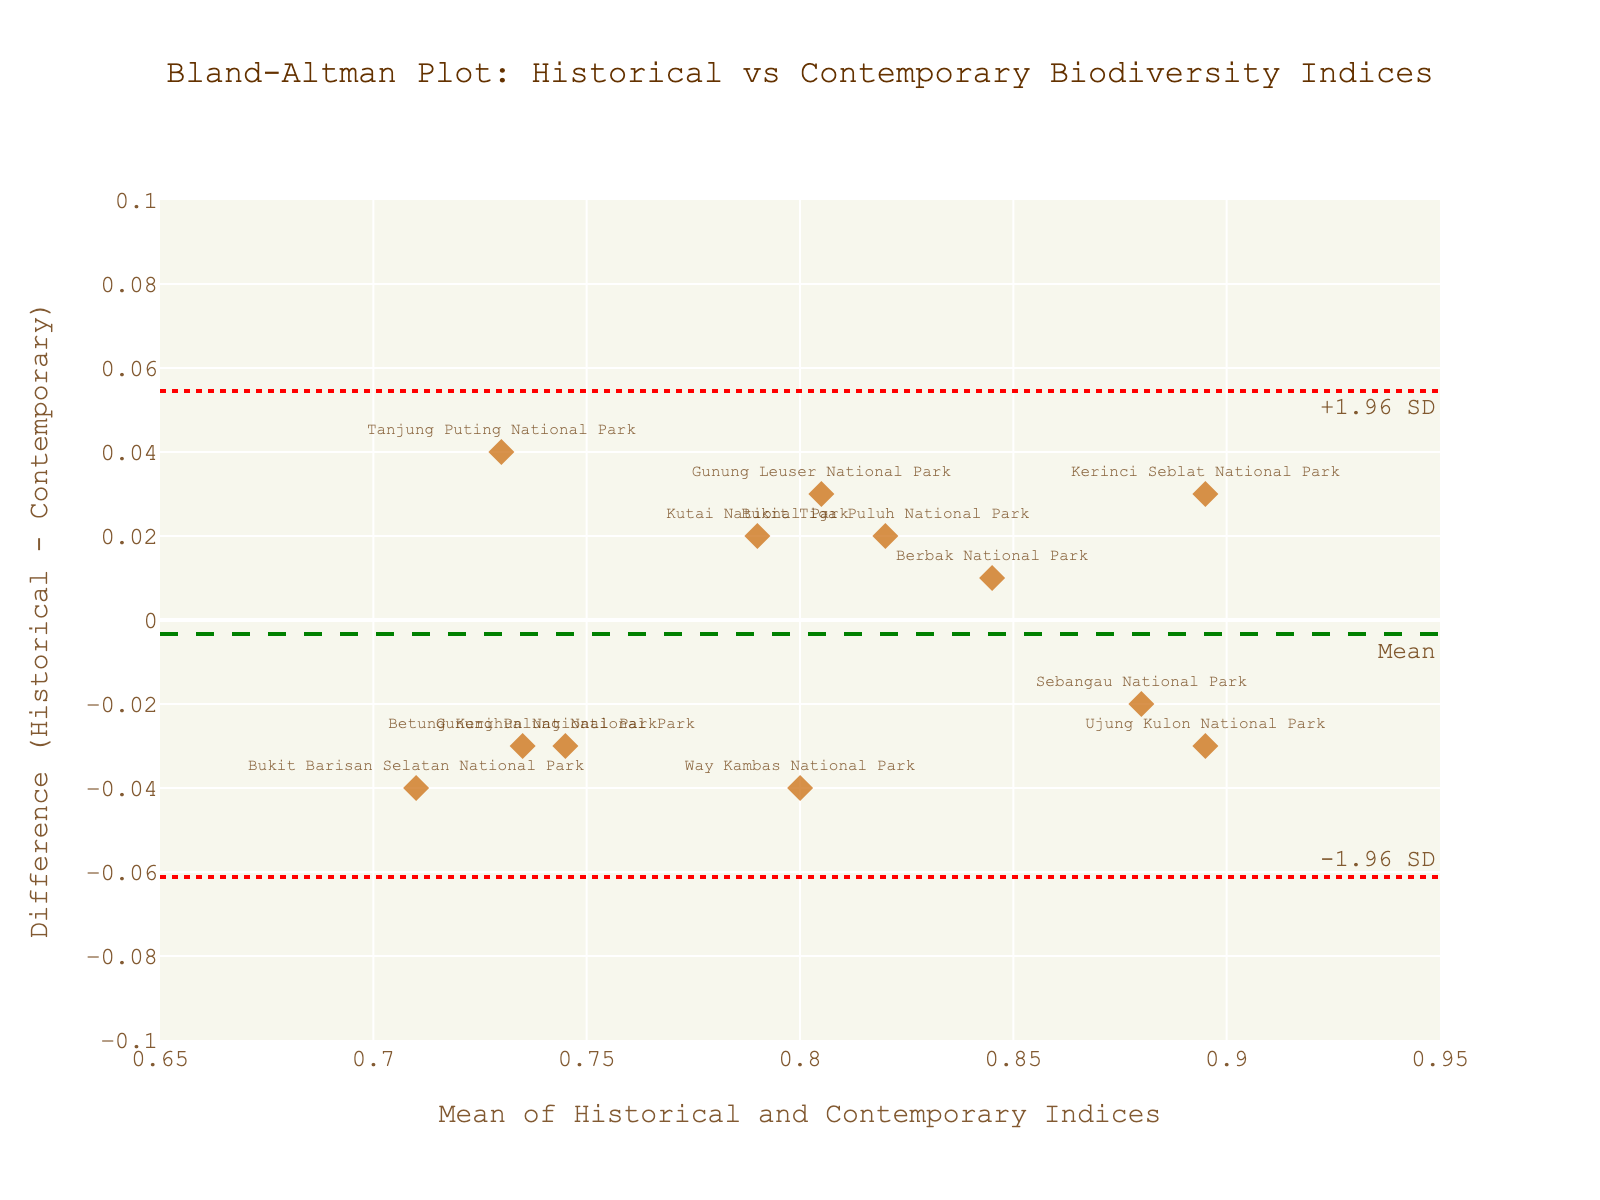What is the title of the figure? Look at the top of the figure where the title is displayed in a large font.
Answer: Bland-Altman Plot: Historical vs Contemporary Biodiversity Indices What are the x-axis and y-axis titles on the plot? The x-axis title is at the bottom of the plot, and the y-axis title is to the left of the plot.
Answer: x-axis: Mean of Historical and Contemporary Indices, y-axis: Difference (Historical - Contemporary) How many data points are there in the plot? Count the total number of markers (diamonds) on the plot.
Answer: 12 Which national park is represented by the data point with the largest positive difference? Identify the data point with the highest y-value and check the associated label.
Answer: Kerinci Seblat National Park What is the mean difference between the historical and contemporary indices? Locate the horizontal line labeled "Mean" and observe the y-value it crosses.
Answer: 0 What are the upper and lower limits of agreement? Observe the positions of the dashed lines labeled "+1.96 SD" and "-1.96 SD" on the plot and note their y-values.
Answer: Upper: ~0.066, Lower: ~-0.066 Which national park has a difference closest to zero? Identify the data point closest to the zero line on the y-axis and check the associated label.
Answer: Berbak National Park What range does the x-axis cover? Check the numerical limits of the x-axis displayed at the bottom of the plot.
Answer: 0.65 to 0.95 What symbol and color represent the data points? Look at the shape and color of the markers used in the plot.
Answer: Color: Orange, Symbol: Diamond Is there a national park where the contemporary index is higher than the historical index? Identify any data points with negative y-values, as this indicates the contemporary index is higher.
Answer: Yes, for example, Tanjung Puting National Park (difference is negative) 